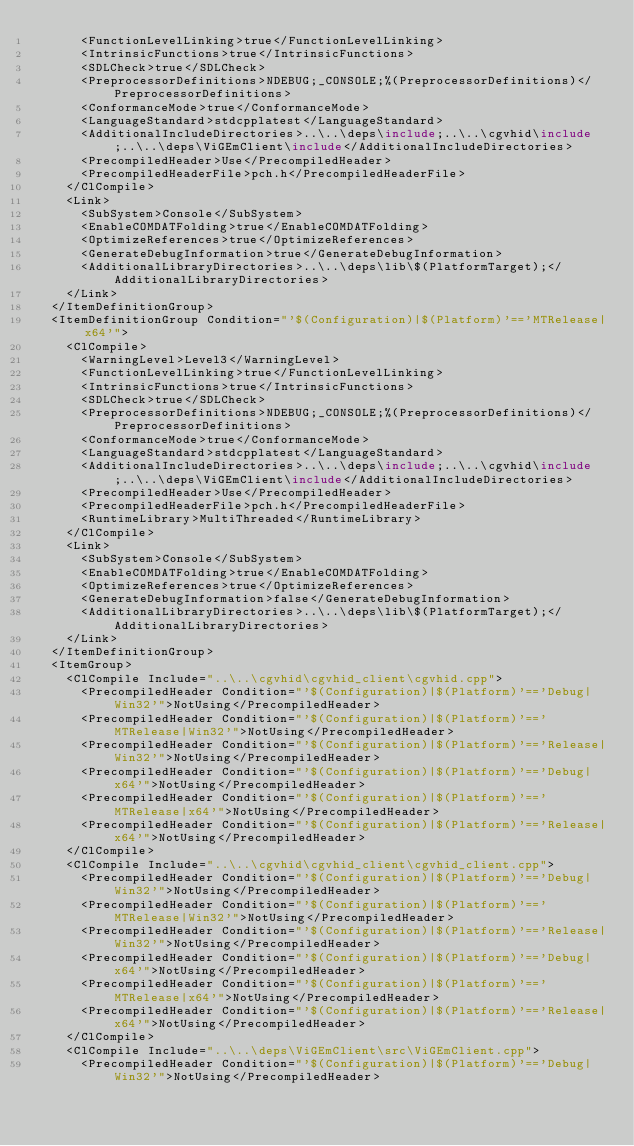Convert code to text. <code><loc_0><loc_0><loc_500><loc_500><_XML_>      <FunctionLevelLinking>true</FunctionLevelLinking>
      <IntrinsicFunctions>true</IntrinsicFunctions>
      <SDLCheck>true</SDLCheck>
      <PreprocessorDefinitions>NDEBUG;_CONSOLE;%(PreprocessorDefinitions)</PreprocessorDefinitions>
      <ConformanceMode>true</ConformanceMode>
      <LanguageStandard>stdcpplatest</LanguageStandard>
      <AdditionalIncludeDirectories>..\..\deps\include;..\..\cgvhid\include;..\..\deps\ViGEmClient\include</AdditionalIncludeDirectories>
      <PrecompiledHeader>Use</PrecompiledHeader>
      <PrecompiledHeaderFile>pch.h</PrecompiledHeaderFile>
    </ClCompile>
    <Link>
      <SubSystem>Console</SubSystem>
      <EnableCOMDATFolding>true</EnableCOMDATFolding>
      <OptimizeReferences>true</OptimizeReferences>
      <GenerateDebugInformation>true</GenerateDebugInformation>
      <AdditionalLibraryDirectories>..\..\deps\lib\$(PlatformTarget);</AdditionalLibraryDirectories>
    </Link>
  </ItemDefinitionGroup>
  <ItemDefinitionGroup Condition="'$(Configuration)|$(Platform)'=='MTRelease|x64'">
    <ClCompile>
      <WarningLevel>Level3</WarningLevel>
      <FunctionLevelLinking>true</FunctionLevelLinking>
      <IntrinsicFunctions>true</IntrinsicFunctions>
      <SDLCheck>true</SDLCheck>
      <PreprocessorDefinitions>NDEBUG;_CONSOLE;%(PreprocessorDefinitions)</PreprocessorDefinitions>
      <ConformanceMode>true</ConformanceMode>
      <LanguageStandard>stdcpplatest</LanguageStandard>
      <AdditionalIncludeDirectories>..\..\deps\include;..\..\cgvhid\include;..\..\deps\ViGEmClient\include</AdditionalIncludeDirectories>
      <PrecompiledHeader>Use</PrecompiledHeader>
      <PrecompiledHeaderFile>pch.h</PrecompiledHeaderFile>
      <RuntimeLibrary>MultiThreaded</RuntimeLibrary>
    </ClCompile>
    <Link>
      <SubSystem>Console</SubSystem>
      <EnableCOMDATFolding>true</EnableCOMDATFolding>
      <OptimizeReferences>true</OptimizeReferences>
      <GenerateDebugInformation>false</GenerateDebugInformation>
      <AdditionalLibraryDirectories>..\..\deps\lib\$(PlatformTarget);</AdditionalLibraryDirectories>
    </Link>
  </ItemDefinitionGroup>
  <ItemGroup>
    <ClCompile Include="..\..\cgvhid\cgvhid_client\cgvhid.cpp">
      <PrecompiledHeader Condition="'$(Configuration)|$(Platform)'=='Debug|Win32'">NotUsing</PrecompiledHeader>
      <PrecompiledHeader Condition="'$(Configuration)|$(Platform)'=='MTRelease|Win32'">NotUsing</PrecompiledHeader>
      <PrecompiledHeader Condition="'$(Configuration)|$(Platform)'=='Release|Win32'">NotUsing</PrecompiledHeader>
      <PrecompiledHeader Condition="'$(Configuration)|$(Platform)'=='Debug|x64'">NotUsing</PrecompiledHeader>
      <PrecompiledHeader Condition="'$(Configuration)|$(Platform)'=='MTRelease|x64'">NotUsing</PrecompiledHeader>
      <PrecompiledHeader Condition="'$(Configuration)|$(Platform)'=='Release|x64'">NotUsing</PrecompiledHeader>
    </ClCompile>
    <ClCompile Include="..\..\cgvhid\cgvhid_client\cgvhid_client.cpp">
      <PrecompiledHeader Condition="'$(Configuration)|$(Platform)'=='Debug|Win32'">NotUsing</PrecompiledHeader>
      <PrecompiledHeader Condition="'$(Configuration)|$(Platform)'=='MTRelease|Win32'">NotUsing</PrecompiledHeader>
      <PrecompiledHeader Condition="'$(Configuration)|$(Platform)'=='Release|Win32'">NotUsing</PrecompiledHeader>
      <PrecompiledHeader Condition="'$(Configuration)|$(Platform)'=='Debug|x64'">NotUsing</PrecompiledHeader>
      <PrecompiledHeader Condition="'$(Configuration)|$(Platform)'=='MTRelease|x64'">NotUsing</PrecompiledHeader>
      <PrecompiledHeader Condition="'$(Configuration)|$(Platform)'=='Release|x64'">NotUsing</PrecompiledHeader>
    </ClCompile>
    <ClCompile Include="..\..\deps\ViGEmClient\src\ViGEmClient.cpp">
      <PrecompiledHeader Condition="'$(Configuration)|$(Platform)'=='Debug|Win32'">NotUsing</PrecompiledHeader></code> 